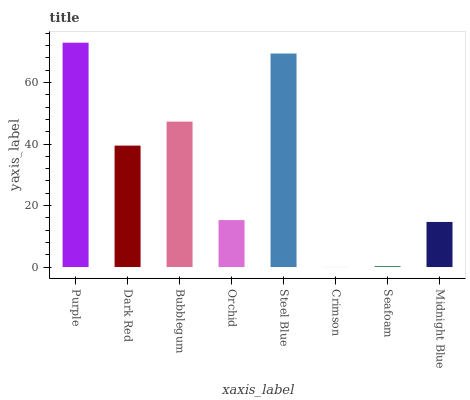Is Dark Red the minimum?
Answer yes or no. No. Is Dark Red the maximum?
Answer yes or no. No. Is Purple greater than Dark Red?
Answer yes or no. Yes. Is Dark Red less than Purple?
Answer yes or no. Yes. Is Dark Red greater than Purple?
Answer yes or no. No. Is Purple less than Dark Red?
Answer yes or no. No. Is Dark Red the high median?
Answer yes or no. Yes. Is Orchid the low median?
Answer yes or no. Yes. Is Bubblegum the high median?
Answer yes or no. No. Is Dark Red the low median?
Answer yes or no. No. 